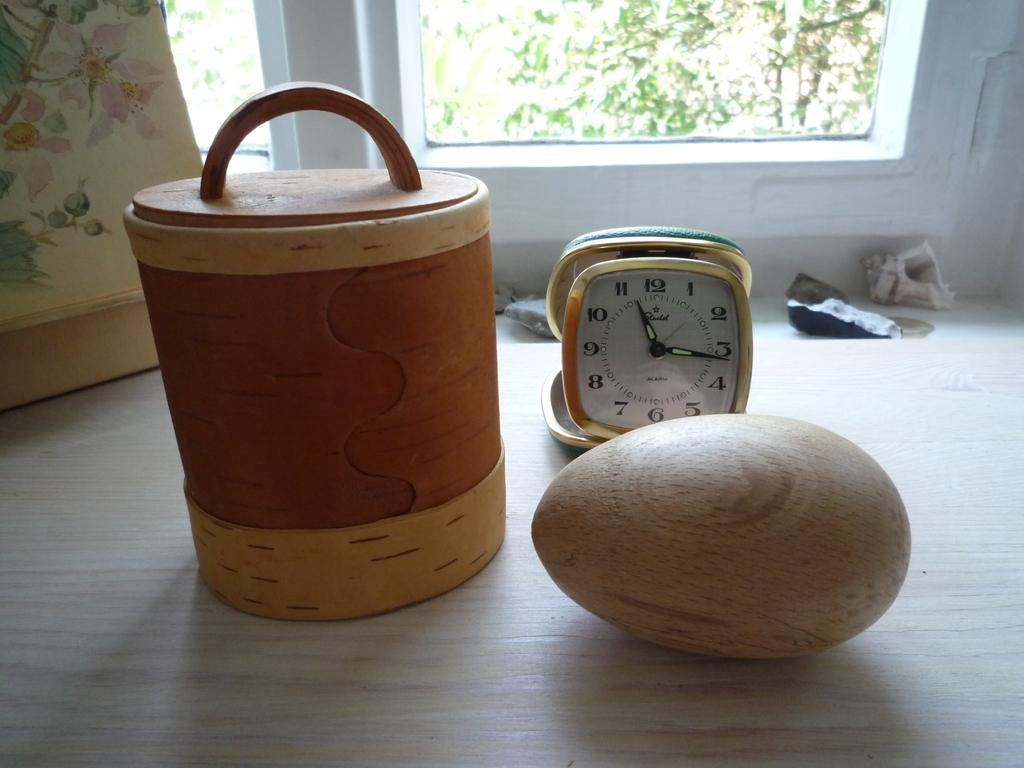Provide a one-sentence caption for the provided image. A table with a wooden football, a clock that is set at 11:15, and a basket on a table next to each other. 